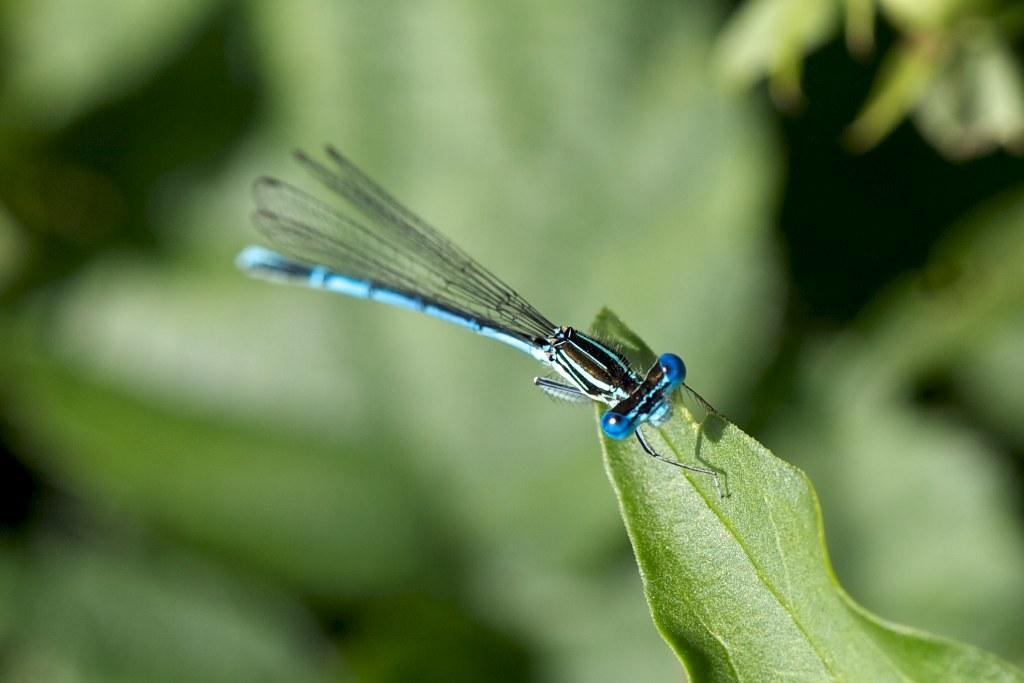What is the main subject of the picture? The main subject of the picture is an insect. Where is the insect located in the image? The insect is on a leaf. Can you describe the background of the image? The background of the image is blurry. What type of knot is the insect using to secure itself to the leaf? There is no knot present in the image, as insects do not use knots to secure themselves to leaves. 